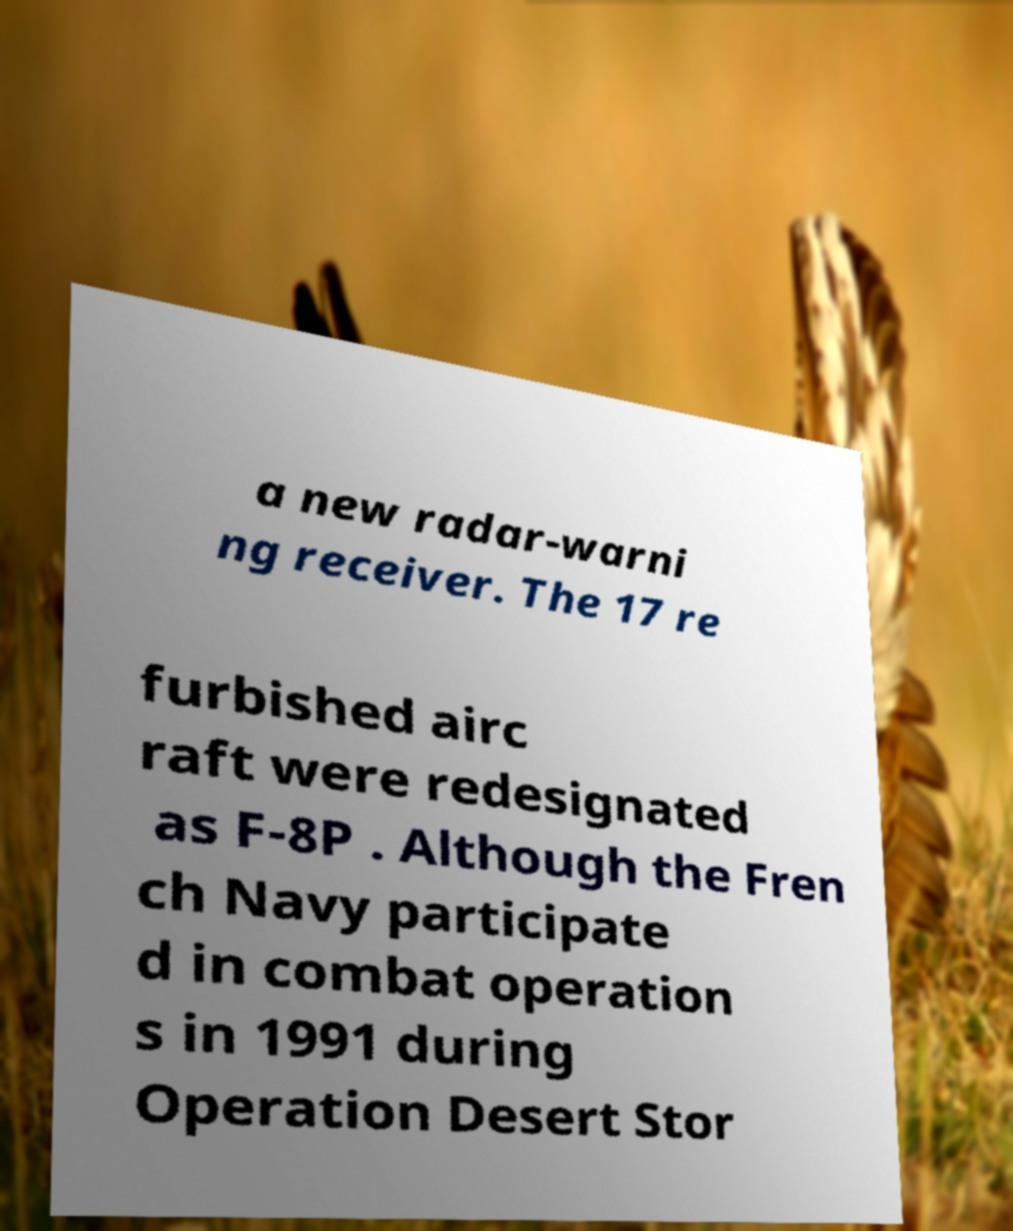What messages or text are displayed in this image? I need them in a readable, typed format. a new radar-warni ng receiver. The 17 re furbished airc raft were redesignated as F-8P . Although the Fren ch Navy participate d in combat operation s in 1991 during Operation Desert Stor 